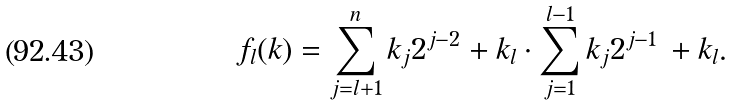<formula> <loc_0><loc_0><loc_500><loc_500>f _ { l } ( k ) = \sum _ { j = l + 1 } ^ { n } k _ { j } 2 ^ { j - 2 } + k _ { l } \cdot \sum _ { j = 1 } ^ { l - 1 } k _ { j } 2 ^ { j - 1 } \, + k _ { l } .</formula> 